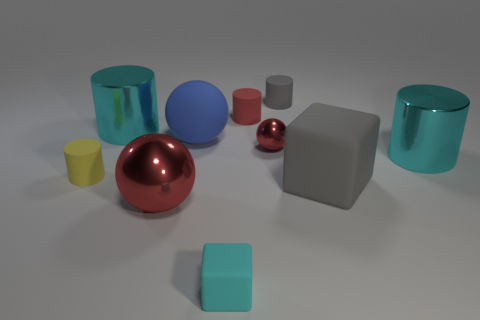What are the color variations among these objects? The objects display a palette of colors including red, blue, teal, yellow, and grey. The colors range from vivid, like the bright teal and red, to more muted tones such as the grey. The differences in color and saturation add to the visual interest of the scene. 